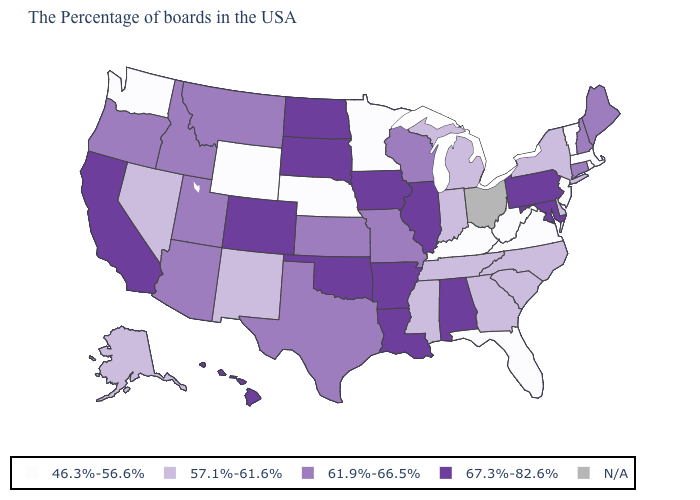What is the highest value in the USA?
Short answer required. 67.3%-82.6%. What is the lowest value in the MidWest?
Write a very short answer. 46.3%-56.6%. What is the value of Vermont?
Write a very short answer. 46.3%-56.6%. How many symbols are there in the legend?
Short answer required. 5. Among the states that border Connecticut , does Rhode Island have the lowest value?
Write a very short answer. Yes. Which states have the lowest value in the USA?
Give a very brief answer. Massachusetts, Rhode Island, Vermont, New Jersey, Virginia, West Virginia, Florida, Kentucky, Minnesota, Nebraska, Wyoming, Washington. What is the value of Delaware?
Answer briefly. 57.1%-61.6%. Among the states that border Colorado , does Arizona have the lowest value?
Quick response, please. No. What is the value of California?
Answer briefly. 67.3%-82.6%. Does the map have missing data?
Give a very brief answer. Yes. Which states have the lowest value in the West?
Short answer required. Wyoming, Washington. Name the states that have a value in the range 57.1%-61.6%?
Give a very brief answer. New York, Delaware, North Carolina, South Carolina, Georgia, Michigan, Indiana, Tennessee, Mississippi, New Mexico, Nevada, Alaska. What is the value of Vermont?
Short answer required. 46.3%-56.6%. Name the states that have a value in the range N/A?
Keep it brief. Ohio. 